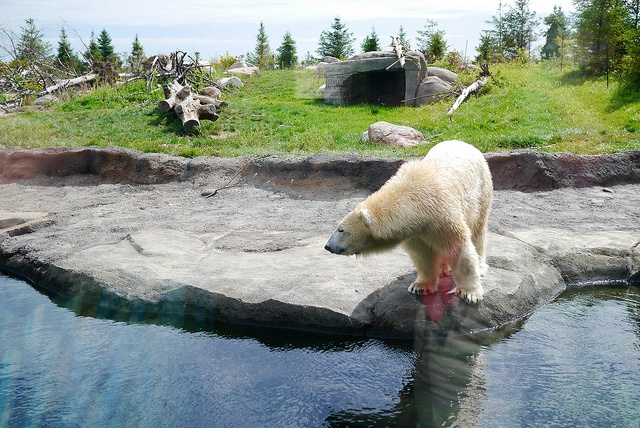Describe the objects in this image and their specific colors. I can see a bear in lightblue, ivory, darkgray, and gray tones in this image. 